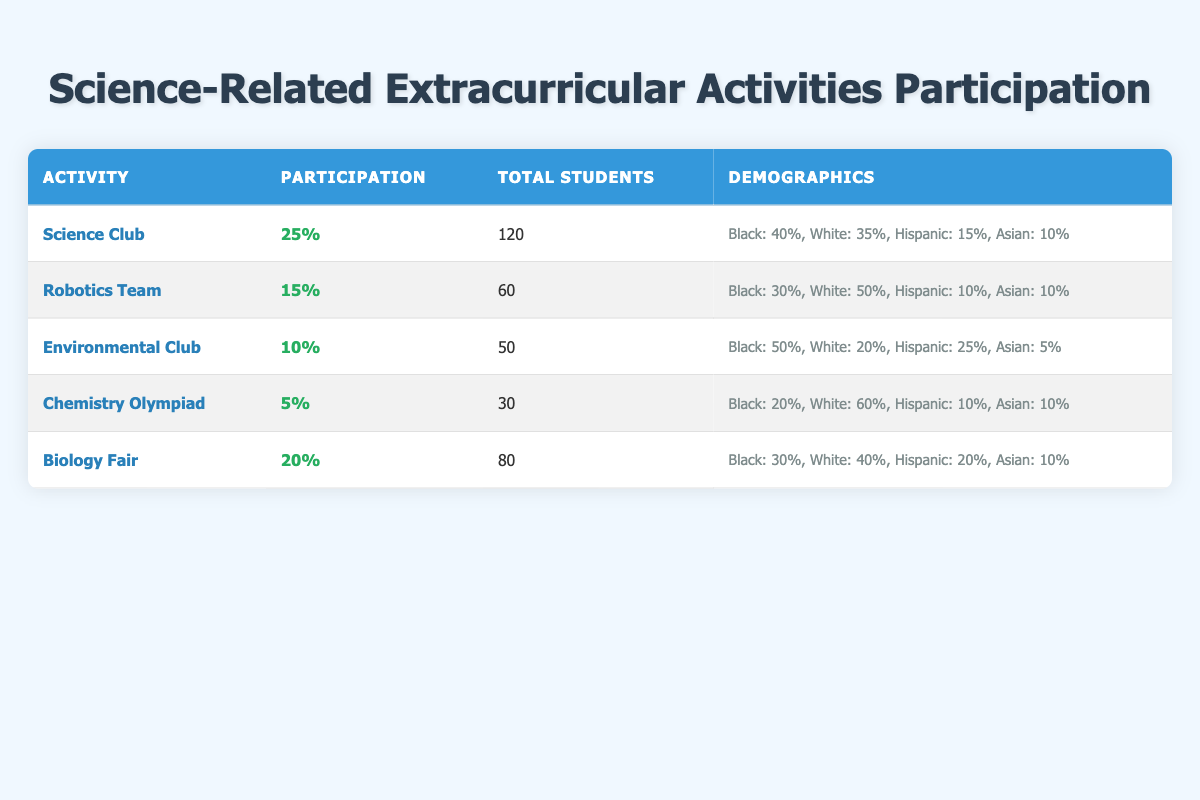What is the total number of students in the Science Club? The table states that there are 120 total students in the Science Club.
Answer: 120 Which extracurricular activity has the highest participation percentage? The Science Club has the highest participation percentage of 25%.
Answer: Science Club What percentage of students in the Environmental Club are Black? The table indicates that 50% of the students in the Environmental Club identify as Black.
Answer: 50% How many students in the Robotics Team are Hispanic? There are 60 total students in the Robotics Team, with 10% being Hispanic. Thus, 10% of 60 is calculated as (10/100) * 60 = 6.
Answer: 6 What is the average participation percentage of all the activities listed? The activities have participation percentages of 25, 15, 10, 5, and 20. To find the average, sum these percentages (25 + 15 + 10 + 5 + 20 = 75) and divide by the number of activities (75 / 5 = 15).
Answer: 15 Is the percentage of Black students in the Chemistry Olympiad lower than that in the Biology Fair? The Chemistry Olympiad has 20% Black students while the Biology Fair has 30%. Since 20% is less than 30%, the answer is yes.
Answer: Yes How many more students are involved in the Biology Fair compared to the Environmental Club? The Biology Fair has 80 students, while the Environmental Club has 50. Thus, the difference is 80 - 50 = 30 students involved in the Biology Fair.
Answer: 30 Which activity has the lowest total student participation? The Chemistry Olympiad has the lowest number of total students, with only 30 participants.
Answer: Chemistry Olympiad What percentage of students in the Robotics Team are White? The Robotics Team has 50% of its students identifying as White.
Answer: 50% 